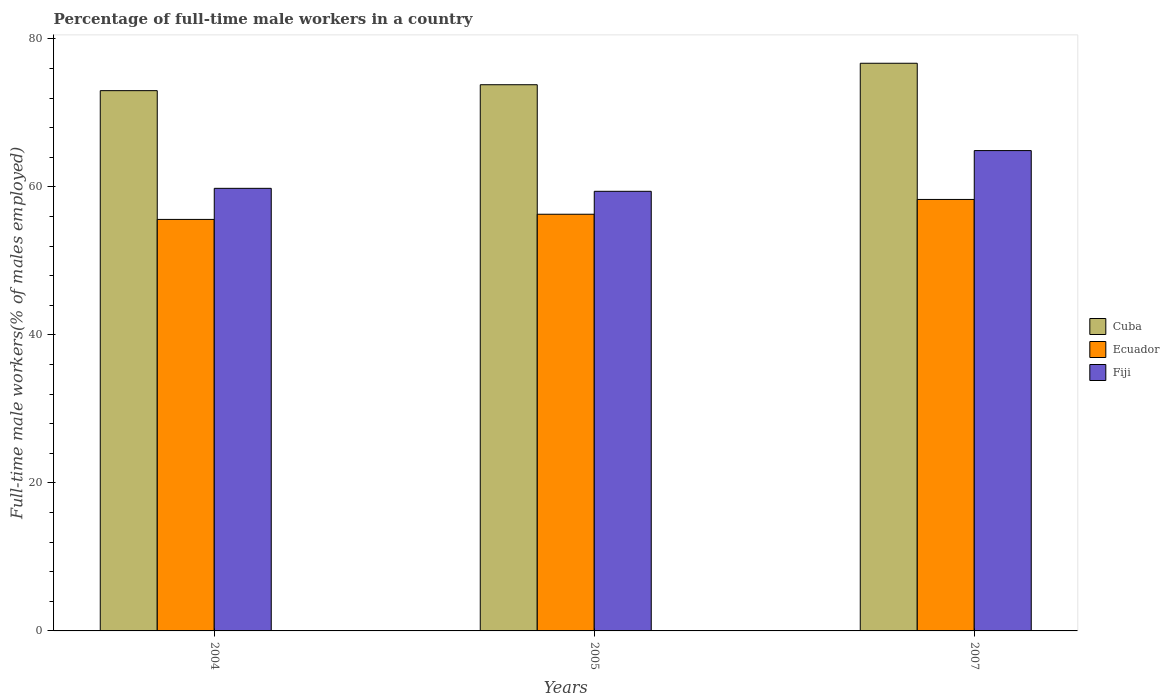Are the number of bars per tick equal to the number of legend labels?
Your answer should be very brief. Yes. How many bars are there on the 1st tick from the left?
Provide a succinct answer. 3. How many bars are there on the 1st tick from the right?
Offer a very short reply. 3. What is the label of the 1st group of bars from the left?
Offer a terse response. 2004. What is the percentage of full-time male workers in Ecuador in 2007?
Offer a very short reply. 58.3. Across all years, what is the maximum percentage of full-time male workers in Ecuador?
Ensure brevity in your answer.  58.3. Across all years, what is the minimum percentage of full-time male workers in Fiji?
Offer a very short reply. 59.4. What is the total percentage of full-time male workers in Fiji in the graph?
Keep it short and to the point. 184.1. What is the difference between the percentage of full-time male workers in Fiji in 2004 and that in 2007?
Your response must be concise. -5.1. What is the difference between the percentage of full-time male workers in Cuba in 2007 and the percentage of full-time male workers in Ecuador in 2004?
Keep it short and to the point. 21.1. What is the average percentage of full-time male workers in Fiji per year?
Give a very brief answer. 61.37. In the year 2007, what is the difference between the percentage of full-time male workers in Fiji and percentage of full-time male workers in Cuba?
Ensure brevity in your answer.  -11.8. In how many years, is the percentage of full-time male workers in Cuba greater than 76 %?
Give a very brief answer. 1. What is the ratio of the percentage of full-time male workers in Cuba in 2004 to that in 2005?
Provide a succinct answer. 0.99. Is the percentage of full-time male workers in Fiji in 2005 less than that in 2007?
Give a very brief answer. Yes. Is the difference between the percentage of full-time male workers in Fiji in 2005 and 2007 greater than the difference between the percentage of full-time male workers in Cuba in 2005 and 2007?
Give a very brief answer. No. What is the difference between the highest and the second highest percentage of full-time male workers in Fiji?
Provide a short and direct response. 5.1. What is the difference between the highest and the lowest percentage of full-time male workers in Fiji?
Your answer should be compact. 5.5. In how many years, is the percentage of full-time male workers in Cuba greater than the average percentage of full-time male workers in Cuba taken over all years?
Offer a very short reply. 1. Is the sum of the percentage of full-time male workers in Ecuador in 2005 and 2007 greater than the maximum percentage of full-time male workers in Cuba across all years?
Your answer should be very brief. Yes. What does the 3rd bar from the left in 2004 represents?
Offer a terse response. Fiji. What does the 2nd bar from the right in 2005 represents?
Provide a short and direct response. Ecuador. Is it the case that in every year, the sum of the percentage of full-time male workers in Cuba and percentage of full-time male workers in Fiji is greater than the percentage of full-time male workers in Ecuador?
Your answer should be very brief. Yes. Are the values on the major ticks of Y-axis written in scientific E-notation?
Your answer should be very brief. No. Does the graph contain grids?
Make the answer very short. No. Where does the legend appear in the graph?
Your answer should be very brief. Center right. What is the title of the graph?
Your response must be concise. Percentage of full-time male workers in a country. Does "Andorra" appear as one of the legend labels in the graph?
Your response must be concise. No. What is the label or title of the X-axis?
Provide a short and direct response. Years. What is the label or title of the Y-axis?
Make the answer very short. Full-time male workers(% of males employed). What is the Full-time male workers(% of males employed) of Cuba in 2004?
Ensure brevity in your answer.  73. What is the Full-time male workers(% of males employed) in Ecuador in 2004?
Offer a terse response. 55.6. What is the Full-time male workers(% of males employed) of Fiji in 2004?
Offer a terse response. 59.8. What is the Full-time male workers(% of males employed) in Cuba in 2005?
Keep it short and to the point. 73.8. What is the Full-time male workers(% of males employed) in Ecuador in 2005?
Provide a short and direct response. 56.3. What is the Full-time male workers(% of males employed) in Fiji in 2005?
Your response must be concise. 59.4. What is the Full-time male workers(% of males employed) of Cuba in 2007?
Your answer should be very brief. 76.7. What is the Full-time male workers(% of males employed) of Ecuador in 2007?
Offer a very short reply. 58.3. What is the Full-time male workers(% of males employed) of Fiji in 2007?
Provide a short and direct response. 64.9. Across all years, what is the maximum Full-time male workers(% of males employed) of Cuba?
Give a very brief answer. 76.7. Across all years, what is the maximum Full-time male workers(% of males employed) of Ecuador?
Provide a succinct answer. 58.3. Across all years, what is the maximum Full-time male workers(% of males employed) in Fiji?
Give a very brief answer. 64.9. Across all years, what is the minimum Full-time male workers(% of males employed) in Ecuador?
Ensure brevity in your answer.  55.6. Across all years, what is the minimum Full-time male workers(% of males employed) in Fiji?
Offer a terse response. 59.4. What is the total Full-time male workers(% of males employed) in Cuba in the graph?
Provide a short and direct response. 223.5. What is the total Full-time male workers(% of males employed) of Ecuador in the graph?
Your response must be concise. 170.2. What is the total Full-time male workers(% of males employed) in Fiji in the graph?
Make the answer very short. 184.1. What is the difference between the Full-time male workers(% of males employed) in Cuba in 2004 and that in 2005?
Make the answer very short. -0.8. What is the difference between the Full-time male workers(% of males employed) of Ecuador in 2004 and that in 2005?
Your answer should be very brief. -0.7. What is the difference between the Full-time male workers(% of males employed) in Ecuador in 2005 and that in 2007?
Your answer should be very brief. -2. What is the difference between the Full-time male workers(% of males employed) of Cuba in 2004 and the Full-time male workers(% of males employed) of Fiji in 2005?
Give a very brief answer. 13.6. What is the difference between the Full-time male workers(% of males employed) of Ecuador in 2004 and the Full-time male workers(% of males employed) of Fiji in 2005?
Provide a succinct answer. -3.8. What is the difference between the Full-time male workers(% of males employed) of Cuba in 2004 and the Full-time male workers(% of males employed) of Fiji in 2007?
Give a very brief answer. 8.1. What is the difference between the Full-time male workers(% of males employed) in Ecuador in 2004 and the Full-time male workers(% of males employed) in Fiji in 2007?
Make the answer very short. -9.3. What is the average Full-time male workers(% of males employed) in Cuba per year?
Provide a short and direct response. 74.5. What is the average Full-time male workers(% of males employed) of Ecuador per year?
Offer a very short reply. 56.73. What is the average Full-time male workers(% of males employed) of Fiji per year?
Offer a very short reply. 61.37. In the year 2004, what is the difference between the Full-time male workers(% of males employed) in Cuba and Full-time male workers(% of males employed) in Fiji?
Make the answer very short. 13.2. In the year 2005, what is the difference between the Full-time male workers(% of males employed) in Cuba and Full-time male workers(% of males employed) in Ecuador?
Your answer should be compact. 17.5. In the year 2005, what is the difference between the Full-time male workers(% of males employed) in Cuba and Full-time male workers(% of males employed) in Fiji?
Provide a succinct answer. 14.4. In the year 2005, what is the difference between the Full-time male workers(% of males employed) in Ecuador and Full-time male workers(% of males employed) in Fiji?
Keep it short and to the point. -3.1. What is the ratio of the Full-time male workers(% of males employed) of Cuba in 2004 to that in 2005?
Your answer should be compact. 0.99. What is the ratio of the Full-time male workers(% of males employed) of Ecuador in 2004 to that in 2005?
Your answer should be compact. 0.99. What is the ratio of the Full-time male workers(% of males employed) of Fiji in 2004 to that in 2005?
Your answer should be very brief. 1.01. What is the ratio of the Full-time male workers(% of males employed) in Cuba in 2004 to that in 2007?
Keep it short and to the point. 0.95. What is the ratio of the Full-time male workers(% of males employed) of Ecuador in 2004 to that in 2007?
Offer a terse response. 0.95. What is the ratio of the Full-time male workers(% of males employed) in Fiji in 2004 to that in 2007?
Your answer should be compact. 0.92. What is the ratio of the Full-time male workers(% of males employed) in Cuba in 2005 to that in 2007?
Your answer should be compact. 0.96. What is the ratio of the Full-time male workers(% of males employed) of Ecuador in 2005 to that in 2007?
Provide a short and direct response. 0.97. What is the ratio of the Full-time male workers(% of males employed) in Fiji in 2005 to that in 2007?
Your answer should be compact. 0.92. What is the difference between the highest and the second highest Full-time male workers(% of males employed) in Cuba?
Provide a short and direct response. 2.9. What is the difference between the highest and the second highest Full-time male workers(% of males employed) in Fiji?
Make the answer very short. 5.1. What is the difference between the highest and the lowest Full-time male workers(% of males employed) in Fiji?
Your response must be concise. 5.5. 